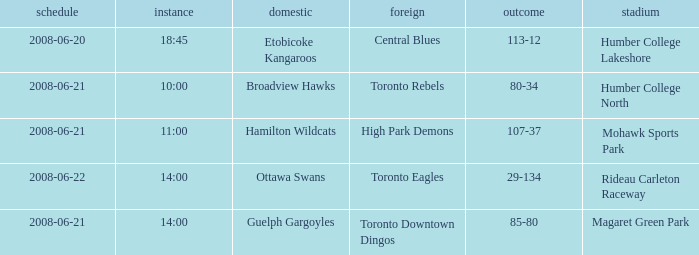What is the Ground with a Date that is 2008-06-20? Humber College Lakeshore. 